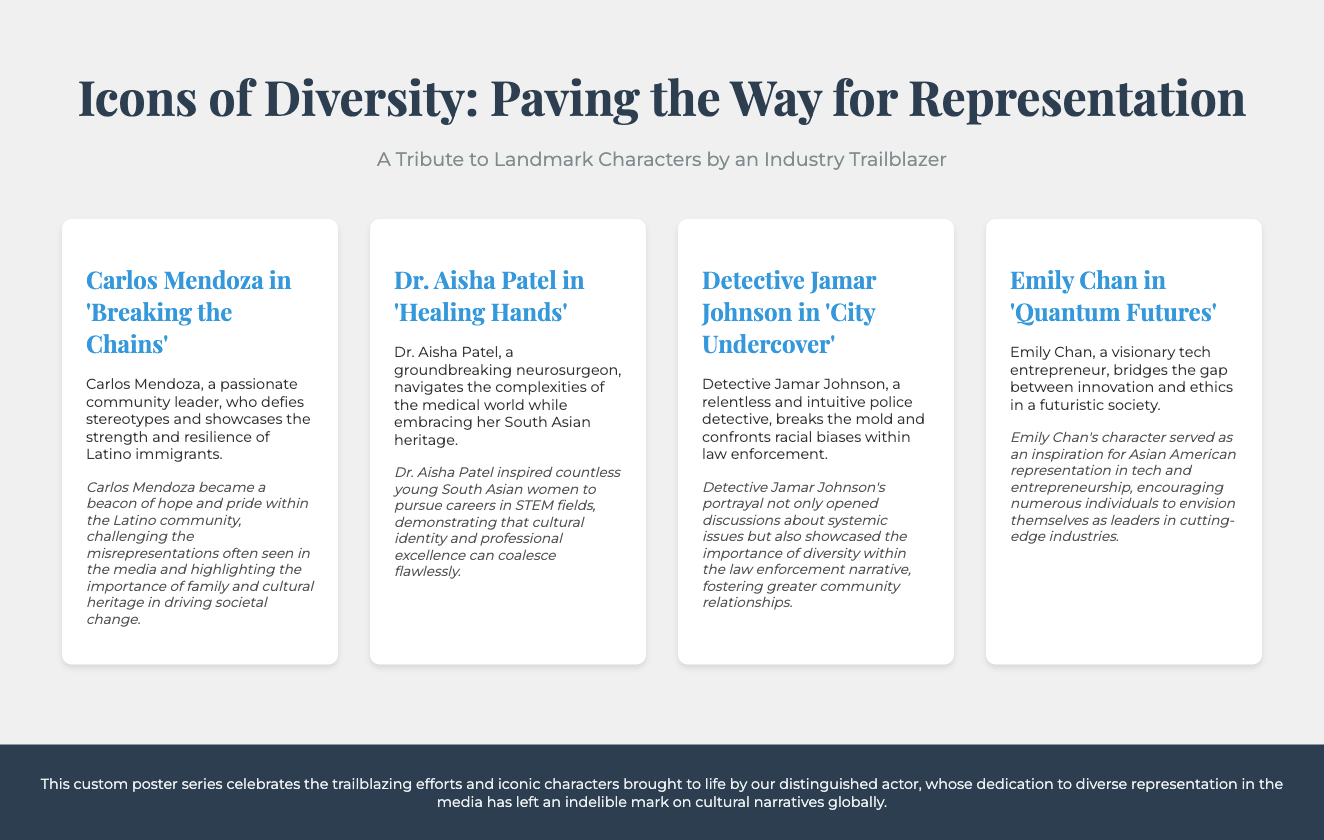What is the title of the custom poster series? The title of the poster series is mentioned at the top of the document.
Answer: Icons of Diversity: Paving the Way for Representation Who portrays Carlos Mendoza? The document states the character and the actor's title.
Answer: An experienced character actor What profession does Dr. Aisha Patel represent? The profession is clearly stated in the character summary section.
Answer: Neurosurgeon In which series does Detective Jamar Johnson appear? The title of the series is included with the character's introduction.
Answer: City Undercover What impact did Emily Chan have on representation? The impact is described in the character's impact section, summing up Emily Chan's influence.
Answer: Encouraging individuals to envision themselves as leaders in industries How many characters are featured in the document? The number of character cards in the character grid directly indicates this information.
Answer: Four What theme does the phrase "Paving the Way for Representation" imply? The phrase suggests a focus on diversity and representation in the media.
Answer: Diversity and representation What effect did Carlos Mendoza have on the Latino community? The specific contribution of the character to the community is outlined in the impact section.
Answer: A beacon of hope and pride What is the role of the footer in the document? The footer typically sums up the content and purpose of the document.
Answer: Celebrates the trailblazing efforts and iconic characters 